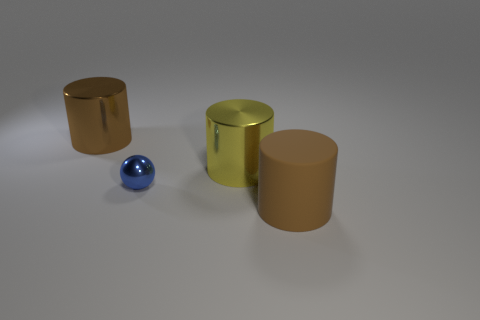Describe the colors of the objects in the image. There are three objects with distinct colors: one cylinder has a reflective gold tone, another cylinder exhibits a translucent green hue, and the sphere has a shiny blue color. 